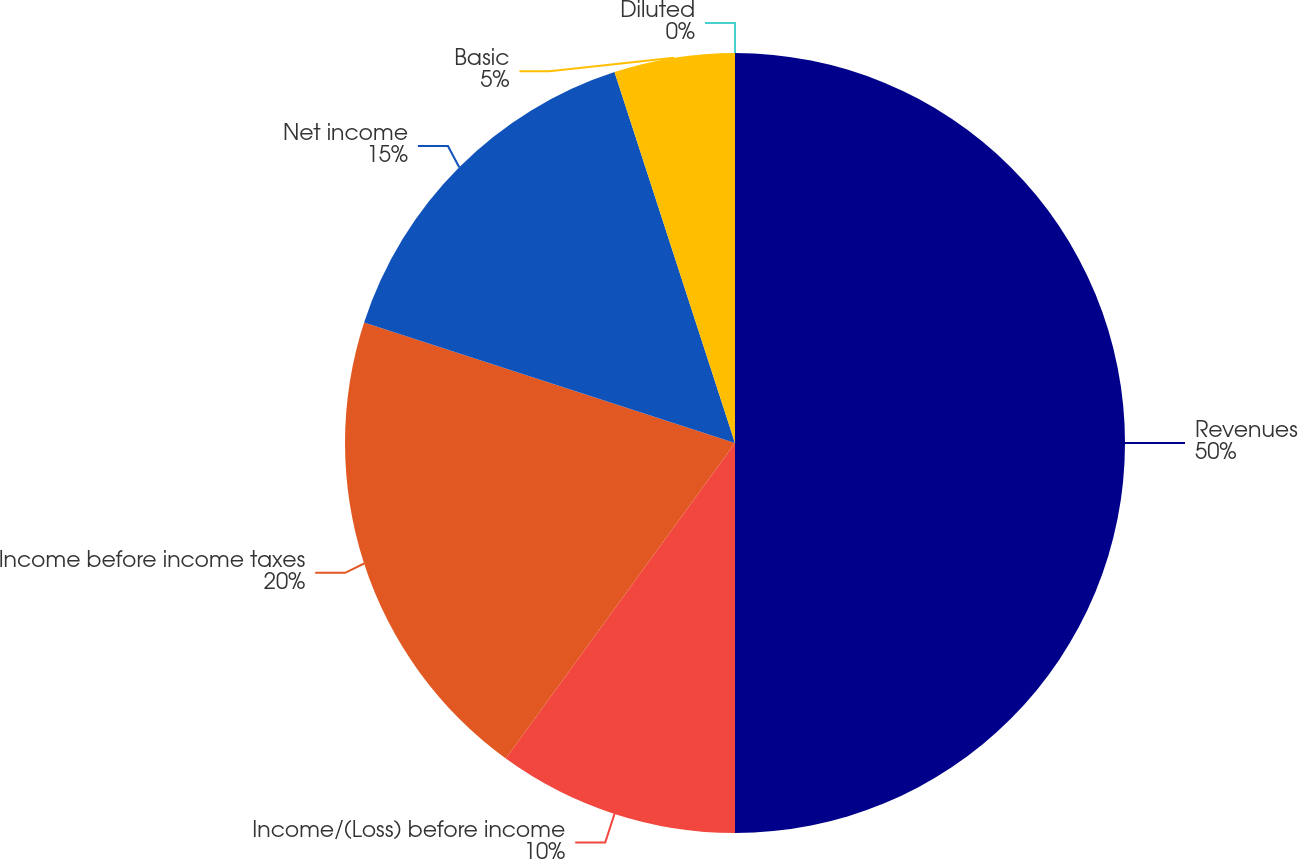Convert chart to OTSL. <chart><loc_0><loc_0><loc_500><loc_500><pie_chart><fcel>Revenues<fcel>Income/(Loss) before income<fcel>Income before income taxes<fcel>Net income<fcel>Basic<fcel>Diluted<nl><fcel>50.0%<fcel>10.0%<fcel>20.0%<fcel>15.0%<fcel>5.0%<fcel>0.0%<nl></chart> 